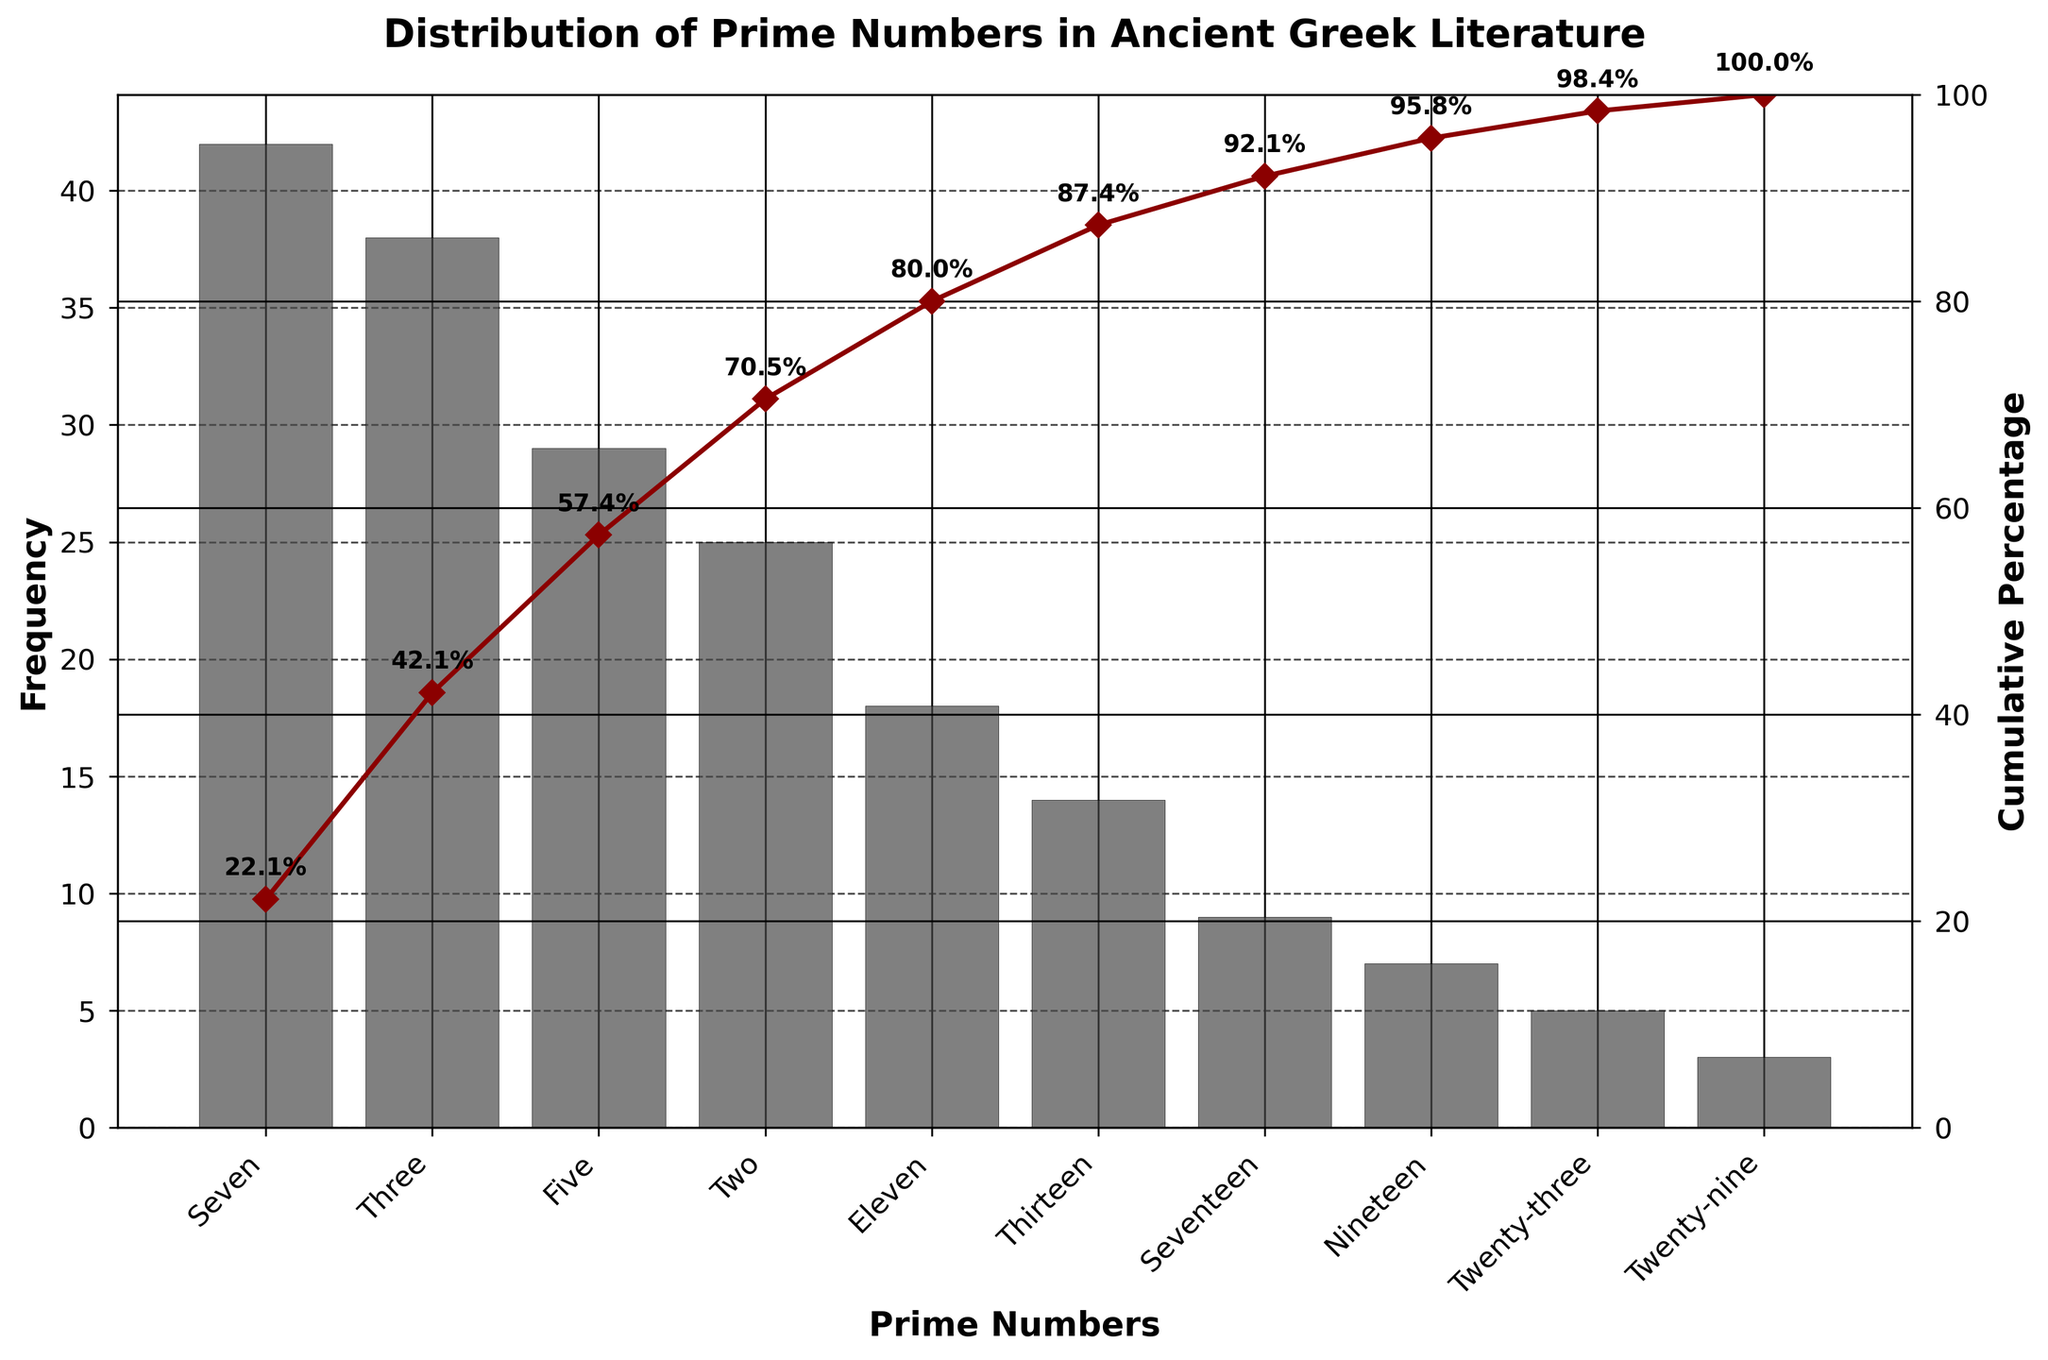What's the total frequency of the two most mentioned prime numbers? The frequencies of the two most mentioned prime numbers, seven and three, are 42 and 38 respectively. Summing them, 42 + 38 results in 80.
Answer: 80 Which prime number has the lowest frequency? The prime number with the lowest frequency is twenty-nine, which has a frequency of 3.
Answer: Twenty-nine How many prime numbers have a frequency greater than 20? Prime numbers with frequencies greater than 20 are seven, three, five, and two. Counting them, there are four in total.
Answer: 4 What percentage of the total frequency do the prime numbers seven and five make up? The total frequency is the sum of frequencies: 42 + 38 + 29 + 25 + 18 + 14 + 9 + 7 + 5 + 3 = 190. The combined frequency of seven and five is 42 + 29 = 71. The percentage is (71 / 190) * 100 which equals approximately 37.4%.
Answer: 37.4% What's the cumulative percentage for the prime number eleven? The cumulative percentage up to eleven includes frequencies for seven, three, five, two, and eleven. Summing the frequencies gives 42 + 38 + 29 + 25 + 18 = 152. The total frequency is 190, so the cumulative percentage is (152 / 190) * 100, which approximates to 80%.
Answer: 80% By how many times is the frequency of seven greater than nineteen? The frequency of seven is 42, and for nineteen, it's 7. Dividing 42 by 7 gives 6. Therefore, seven's frequency is 6 times greater than nineteen's frequency.
Answer: 6 What is the cumulative frequency percentage after the fourth most mentioned prime number? The first four prime numbers are seven, three, five, and two with frequencies of 42, 38, 29, and 25 respectively. Summing these, 42 + 38 + 29 + 25 equals 134. The total frequency is 190, so the cumulative percentage is (134 / 190) * 100, which is approximately 70.5%.
Answer: 70.5% Which two prime numbers’ frequencies add up to 32? The prime numbers with frequencies that add up to 32 are thirteen (14) and nineteen (7). Adding 14 and 7 gives 21, which is not used. The correct sequence 18 (eleven) and 14 (thirteen) adds up to 32.
Answer: Eleven and Thirteen How does the frequency distribution of two and seventeen compare? The frequency of two is 25, while the frequency of seventeen is 9. The difference in frequency between them is 25 - 9, which is 16. Two's frequency is greater than seventeen's.
Answer: Two is 16 greater than seventeen What is the average frequency of all the prime numbers listed? The total frequency is 190. There are 10 prime numbers listed. Dividing the total frequency by the number of prime numbers, 190 / 10 results in an average frequency of 19.
Answer: 19 